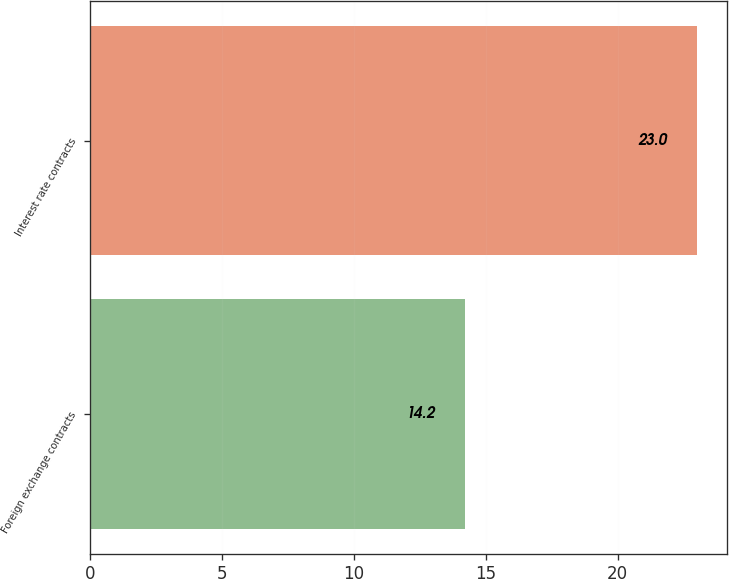Convert chart. <chart><loc_0><loc_0><loc_500><loc_500><bar_chart><fcel>Foreign exchange contracts<fcel>Interest rate contracts<nl><fcel>14.2<fcel>23<nl></chart> 